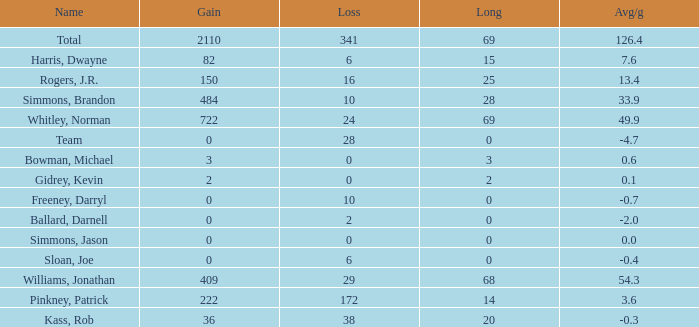Would you mind parsing the complete table? {'header': ['Name', 'Gain', 'Loss', 'Long', 'Avg/g'], 'rows': [['Total', '2110', '341', '69', '126.4'], ['Harris, Dwayne', '82', '6', '15', '7.6'], ['Rogers, J.R.', '150', '16', '25', '13.4'], ['Simmons, Brandon', '484', '10', '28', '33.9'], ['Whitley, Norman', '722', '24', '69', '49.9'], ['Team', '0', '28', '0', '-4.7'], ['Bowman, Michael', '3', '0', '3', '0.6'], ['Gidrey, Kevin', '2', '0', '2', '0.1'], ['Freeney, Darryl', '0', '10', '0', '-0.7'], ['Ballard, Darnell', '0', '2', '0', '-2.0'], ['Simmons, Jason', '0', '0', '0', '0.0'], ['Sloan, Joe', '0', '6', '0', '-0.4'], ['Williams, Jonathan', '409', '29', '68', '54.3'], ['Pinkney, Patrick', '222', '172', '14', '3.6'], ['Kass, Rob', '36', '38', '20', '-0.3']]} What is the highest Loss, when Long is greater than 0, when Gain is greater than 484, and when Avg/g is greater than 126.4? None. 